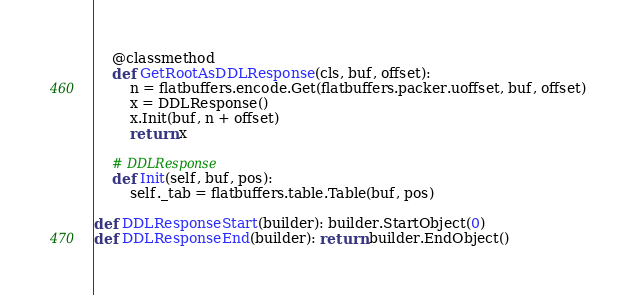Convert code to text. <code><loc_0><loc_0><loc_500><loc_500><_Python_>
    @classmethod
    def GetRootAsDDLResponse(cls, buf, offset):
        n = flatbuffers.encode.Get(flatbuffers.packer.uoffset, buf, offset)
        x = DDLResponse()
        x.Init(buf, n + offset)
        return x

    # DDLResponse
    def Init(self, buf, pos):
        self._tab = flatbuffers.table.Table(buf, pos)

def DDLResponseStart(builder): builder.StartObject(0)
def DDLResponseEnd(builder): return builder.EndObject()
</code> 